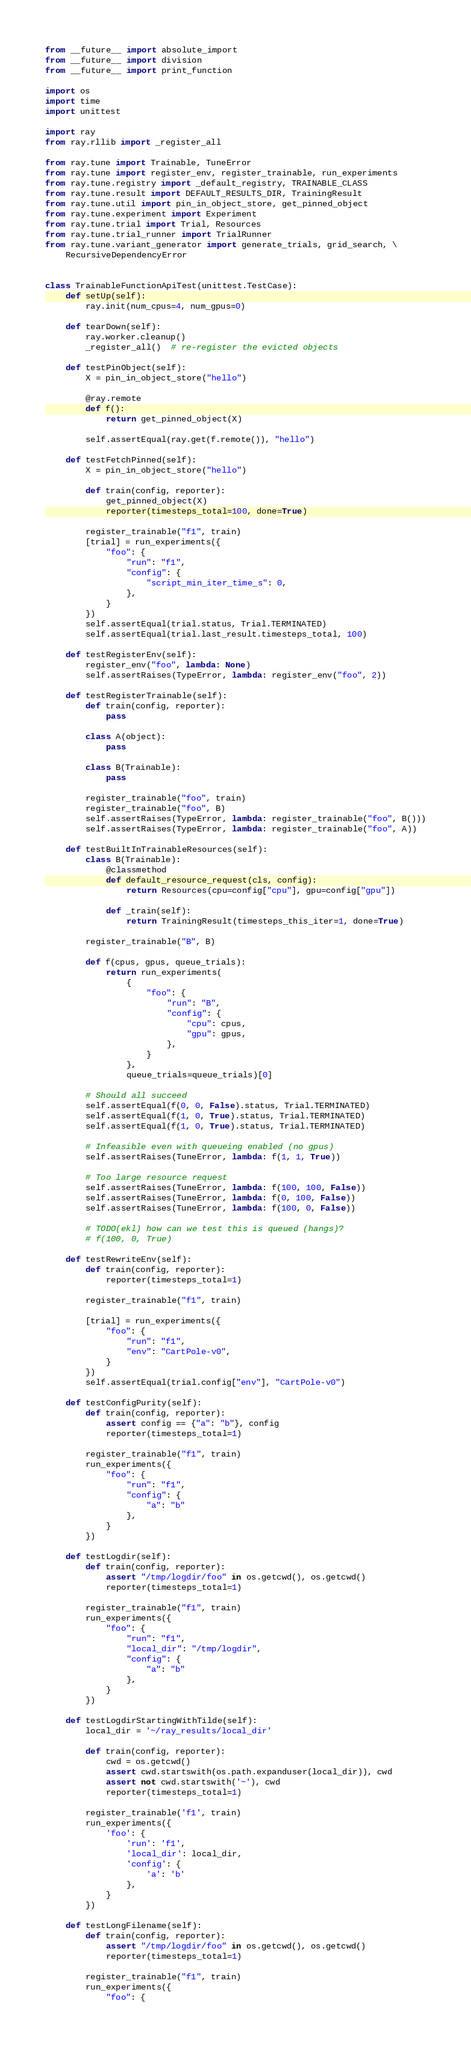Convert code to text. <code><loc_0><loc_0><loc_500><loc_500><_Python_>from __future__ import absolute_import
from __future__ import division
from __future__ import print_function

import os
import time
import unittest

import ray
from ray.rllib import _register_all

from ray.tune import Trainable, TuneError
from ray.tune import register_env, register_trainable, run_experiments
from ray.tune.registry import _default_registry, TRAINABLE_CLASS
from ray.tune.result import DEFAULT_RESULTS_DIR, TrainingResult
from ray.tune.util import pin_in_object_store, get_pinned_object
from ray.tune.experiment import Experiment
from ray.tune.trial import Trial, Resources
from ray.tune.trial_runner import TrialRunner
from ray.tune.variant_generator import generate_trials, grid_search, \
    RecursiveDependencyError


class TrainableFunctionApiTest(unittest.TestCase):
    def setUp(self):
        ray.init(num_cpus=4, num_gpus=0)

    def tearDown(self):
        ray.worker.cleanup()
        _register_all()  # re-register the evicted objects

    def testPinObject(self):
        X = pin_in_object_store("hello")

        @ray.remote
        def f():
            return get_pinned_object(X)

        self.assertEqual(ray.get(f.remote()), "hello")

    def testFetchPinned(self):
        X = pin_in_object_store("hello")

        def train(config, reporter):
            get_pinned_object(X)
            reporter(timesteps_total=100, done=True)

        register_trainable("f1", train)
        [trial] = run_experiments({
            "foo": {
                "run": "f1",
                "config": {
                    "script_min_iter_time_s": 0,
                },
            }
        })
        self.assertEqual(trial.status, Trial.TERMINATED)
        self.assertEqual(trial.last_result.timesteps_total, 100)

    def testRegisterEnv(self):
        register_env("foo", lambda: None)
        self.assertRaises(TypeError, lambda: register_env("foo", 2))

    def testRegisterTrainable(self):
        def train(config, reporter):
            pass

        class A(object):
            pass

        class B(Trainable):
            pass

        register_trainable("foo", train)
        register_trainable("foo", B)
        self.assertRaises(TypeError, lambda: register_trainable("foo", B()))
        self.assertRaises(TypeError, lambda: register_trainable("foo", A))

    def testBuiltInTrainableResources(self):
        class B(Trainable):
            @classmethod
            def default_resource_request(cls, config):
                return Resources(cpu=config["cpu"], gpu=config["gpu"])

            def _train(self):
                return TrainingResult(timesteps_this_iter=1, done=True)

        register_trainable("B", B)

        def f(cpus, gpus, queue_trials):
            return run_experiments(
                {
                    "foo": {
                        "run": "B",
                        "config": {
                            "cpu": cpus,
                            "gpu": gpus,
                        },
                    }
                },
                queue_trials=queue_trials)[0]

        # Should all succeed
        self.assertEqual(f(0, 0, False).status, Trial.TERMINATED)
        self.assertEqual(f(1, 0, True).status, Trial.TERMINATED)
        self.assertEqual(f(1, 0, True).status, Trial.TERMINATED)

        # Infeasible even with queueing enabled (no gpus)
        self.assertRaises(TuneError, lambda: f(1, 1, True))

        # Too large resource request
        self.assertRaises(TuneError, lambda: f(100, 100, False))
        self.assertRaises(TuneError, lambda: f(0, 100, False))
        self.assertRaises(TuneError, lambda: f(100, 0, False))

        # TODO(ekl) how can we test this is queued (hangs)?
        # f(100, 0, True)

    def testRewriteEnv(self):
        def train(config, reporter):
            reporter(timesteps_total=1)

        register_trainable("f1", train)

        [trial] = run_experiments({
            "foo": {
                "run": "f1",
                "env": "CartPole-v0",
            }
        })
        self.assertEqual(trial.config["env"], "CartPole-v0")

    def testConfigPurity(self):
        def train(config, reporter):
            assert config == {"a": "b"}, config
            reporter(timesteps_total=1)

        register_trainable("f1", train)
        run_experiments({
            "foo": {
                "run": "f1",
                "config": {
                    "a": "b"
                },
            }
        })

    def testLogdir(self):
        def train(config, reporter):
            assert "/tmp/logdir/foo" in os.getcwd(), os.getcwd()
            reporter(timesteps_total=1)

        register_trainable("f1", train)
        run_experiments({
            "foo": {
                "run": "f1",
                "local_dir": "/tmp/logdir",
                "config": {
                    "a": "b"
                },
            }
        })

    def testLogdirStartingWithTilde(self):
        local_dir = '~/ray_results/local_dir'

        def train(config, reporter):
            cwd = os.getcwd()
            assert cwd.startswith(os.path.expanduser(local_dir)), cwd
            assert not cwd.startswith('~'), cwd
            reporter(timesteps_total=1)

        register_trainable('f1', train)
        run_experiments({
            'foo': {
                'run': 'f1',
                'local_dir': local_dir,
                'config': {
                    'a': 'b'
                },
            }
        })

    def testLongFilename(self):
        def train(config, reporter):
            assert "/tmp/logdir/foo" in os.getcwd(), os.getcwd()
            reporter(timesteps_total=1)

        register_trainable("f1", train)
        run_experiments({
            "foo": {</code> 